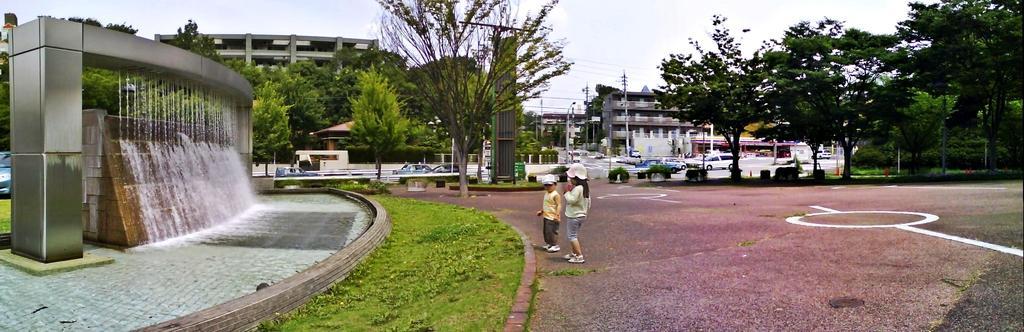How would you summarize this image in a sentence or two? In this image we can see two kids standing on the ground, on left side of the image there is water fountain and in the background of the image there are some trees, vehicles moving on the road, there are some houses and top of the image there is clear sky. 